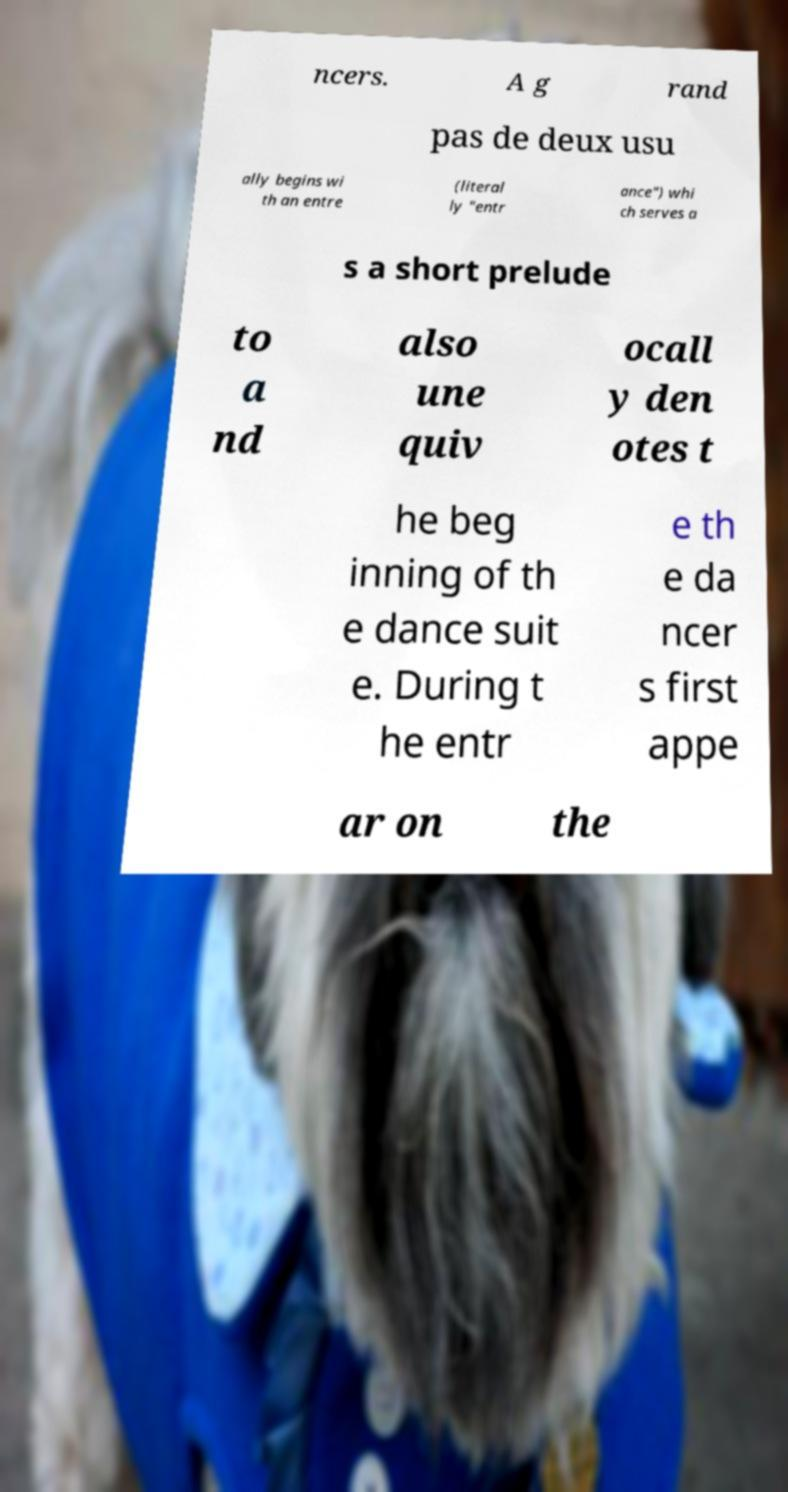Can you accurately transcribe the text from the provided image for me? ncers. A g rand pas de deux usu ally begins wi th an entre (literal ly "entr ance") whi ch serves a s a short prelude to a nd also une quiv ocall y den otes t he beg inning of th e dance suit e. During t he entr e th e da ncer s first appe ar on the 